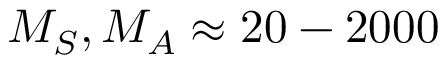Convert formula to latex. <formula><loc_0><loc_0><loc_500><loc_500>M _ { S } , M _ { A } \approx 2 0 - 2 0 0 0</formula> 